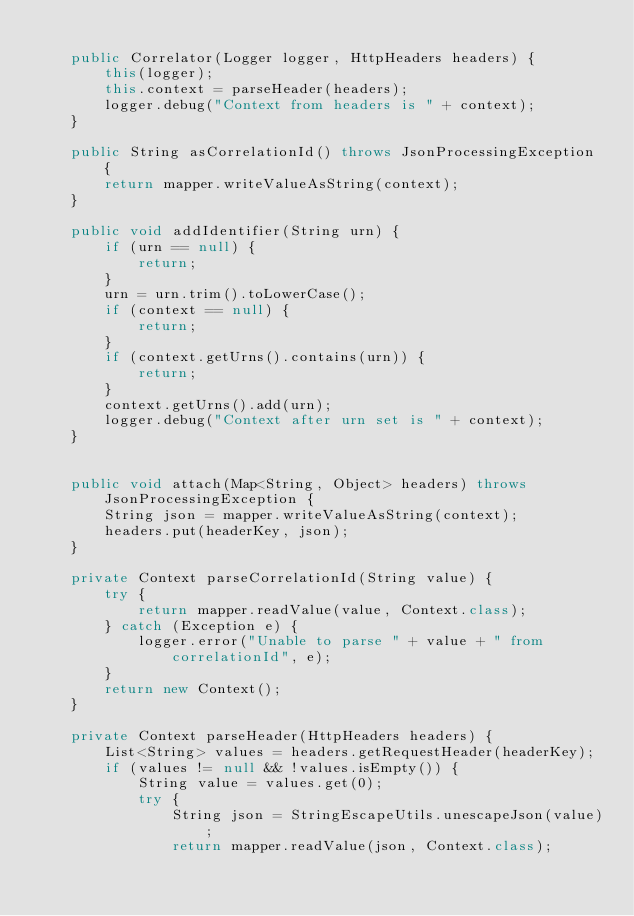<code> <loc_0><loc_0><loc_500><loc_500><_Java_>
	public Correlator(Logger logger, HttpHeaders headers) {
		this(logger);
		this.context = parseHeader(headers);
		logger.debug("Context from headers is " + context);
	}

	public String asCorrelationId() throws JsonProcessingException {
		return mapper.writeValueAsString(context);
	}

	public void addIdentifier(String urn) {
		if (urn == null) {
			return;
		}
		urn = urn.trim().toLowerCase();
		if (context == null) {
			return;
		}
		if (context.getUrns().contains(urn)) {
			return;
		}
		context.getUrns().add(urn);
		logger.debug("Context after urn set is " + context);
	}


	public void attach(Map<String, Object> headers) throws JsonProcessingException {
		String json = mapper.writeValueAsString(context);
		headers.put(headerKey, json);
	}

	private Context parseCorrelationId(String value) {
		try {
			return mapper.readValue(value, Context.class);
		} catch (Exception e) {
			logger.error("Unable to parse " + value + " from correlationId", e);
		}
		return new Context();
	}

	private Context parseHeader(HttpHeaders headers) {
		List<String> values = headers.getRequestHeader(headerKey);
		if (values != null && !values.isEmpty()) {
			String value = values.get(0);
			try {
				String json = StringEscapeUtils.unescapeJson(value);
				return mapper.readValue(json, Context.class);</code> 